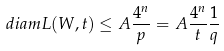<formula> <loc_0><loc_0><loc_500><loc_500>d i a m L ( W , t ) \leq A \frac { 4 ^ { n } } { p } = A \frac { 4 ^ { n } } { t } \frac { 1 } { q }</formula> 